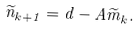<formula> <loc_0><loc_0><loc_500><loc_500>\widetilde { n } _ { k + 1 } = d - A \widetilde { m } _ { k } .</formula> 